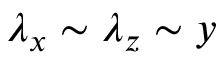<formula> <loc_0><loc_0><loc_500><loc_500>\lambda _ { x } \sim \lambda _ { z } \sim y</formula> 